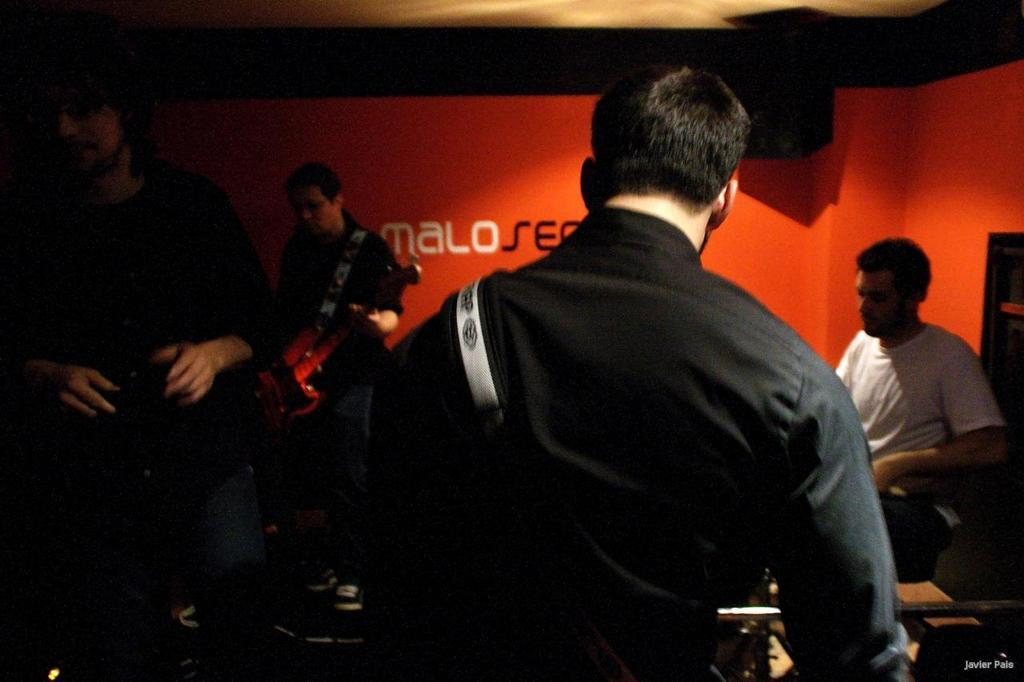How many people are present in the image? There are four people in the image. Where are the people located? The people are in a room. What are the people doing in the image? The people are playing musical instruments. What type of poison is being used by the people in the image? There is no poison present in the image; the people are playing musical instruments. How many babies are visible in the image? There are no babies visible in the image; it features four people playing musical instruments. 